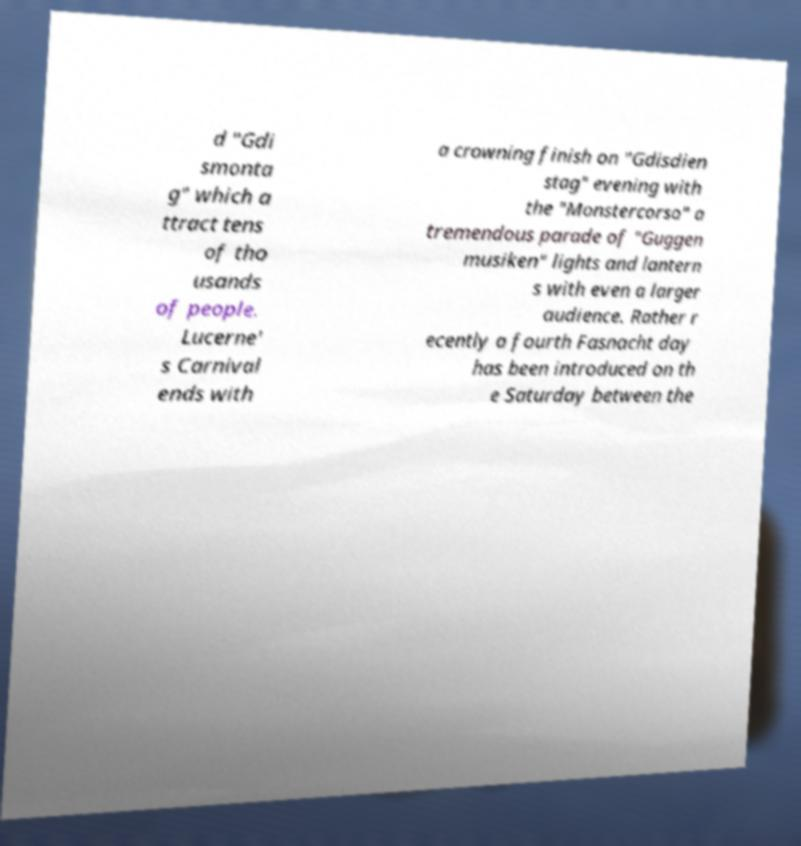Could you assist in decoding the text presented in this image and type it out clearly? d "Gdi smonta g" which a ttract tens of tho usands of people. Lucerne' s Carnival ends with a crowning finish on "Gdisdien stag" evening with the "Monstercorso" a tremendous parade of "Guggen musiken" lights and lantern s with even a larger audience. Rather r ecently a fourth Fasnacht day has been introduced on th e Saturday between the 